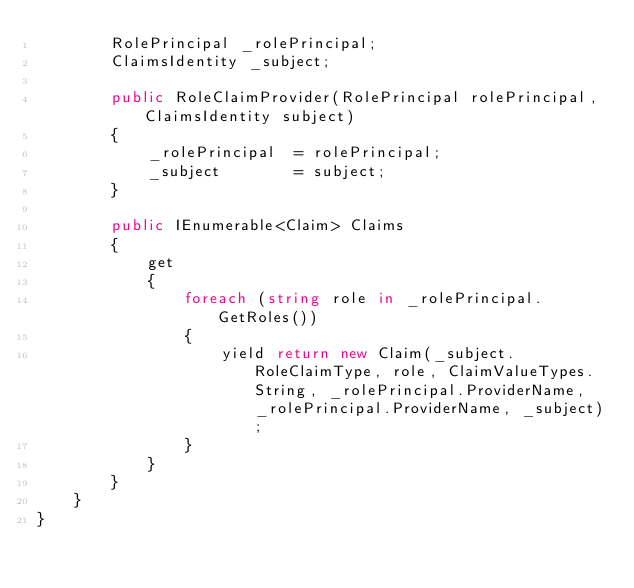Convert code to text. <code><loc_0><loc_0><loc_500><loc_500><_C#_>        RolePrincipal _rolePrincipal;
        ClaimsIdentity _subject;

        public RoleClaimProvider(RolePrincipal rolePrincipal, ClaimsIdentity subject)
        {
            _rolePrincipal  = rolePrincipal;
            _subject        = subject;
        }

        public IEnumerable<Claim> Claims
        {
            get
            {
                foreach (string role in _rolePrincipal.GetRoles())
                {
                    yield return new Claim(_subject.RoleClaimType, role, ClaimValueTypes.String, _rolePrincipal.ProviderName, _rolePrincipal.ProviderName, _subject);
                }
            }
        }
    }
}
</code> 